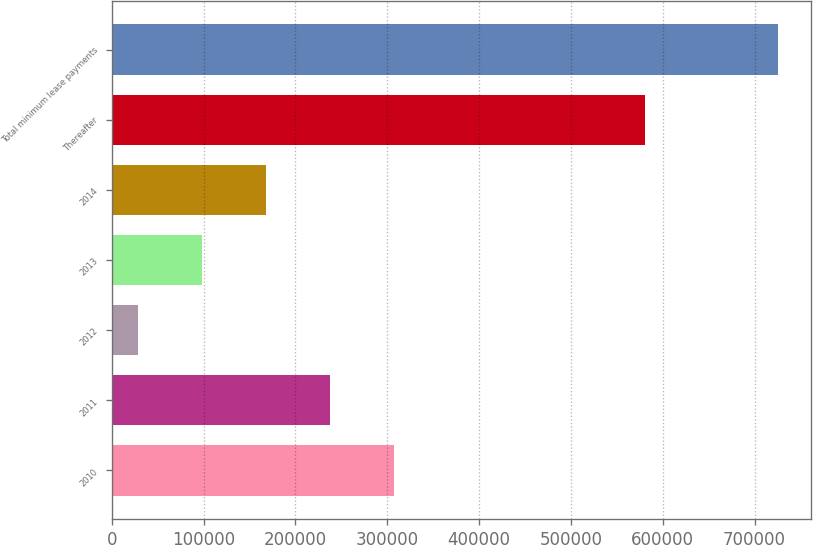Convert chart to OTSL. <chart><loc_0><loc_0><loc_500><loc_500><bar_chart><fcel>2010<fcel>2011<fcel>2012<fcel>2013<fcel>2014<fcel>Thereafter<fcel>Total minimum lease payments<nl><fcel>307073<fcel>237349<fcel>28179<fcel>97902.4<fcel>167626<fcel>580600<fcel>725413<nl></chart> 